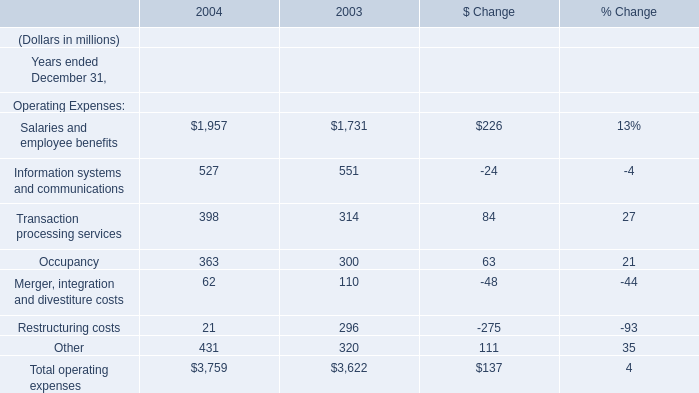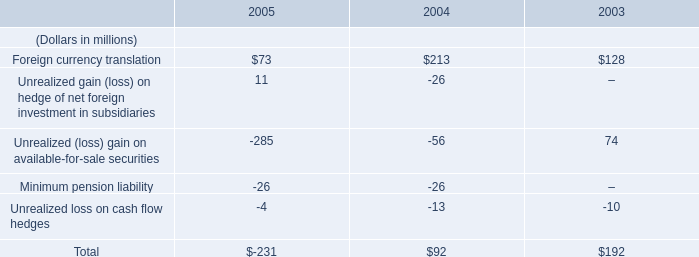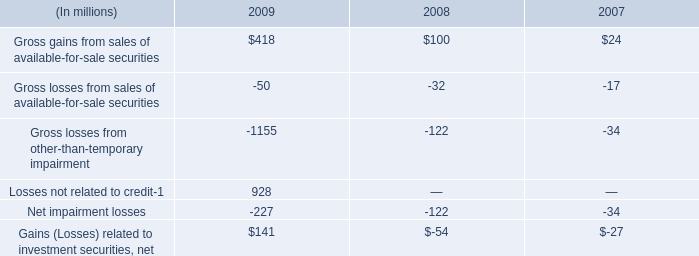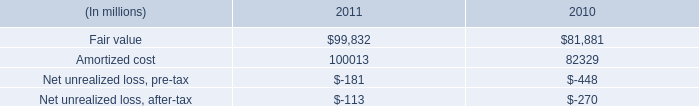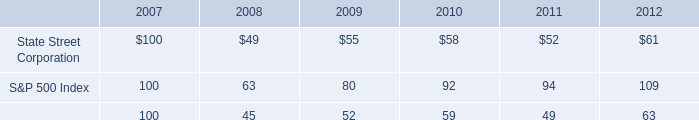what is the roi of an investment in state street corporation from 2007 to 2009? 
Computations: ((55 - 100) / 100)
Answer: -0.45. 